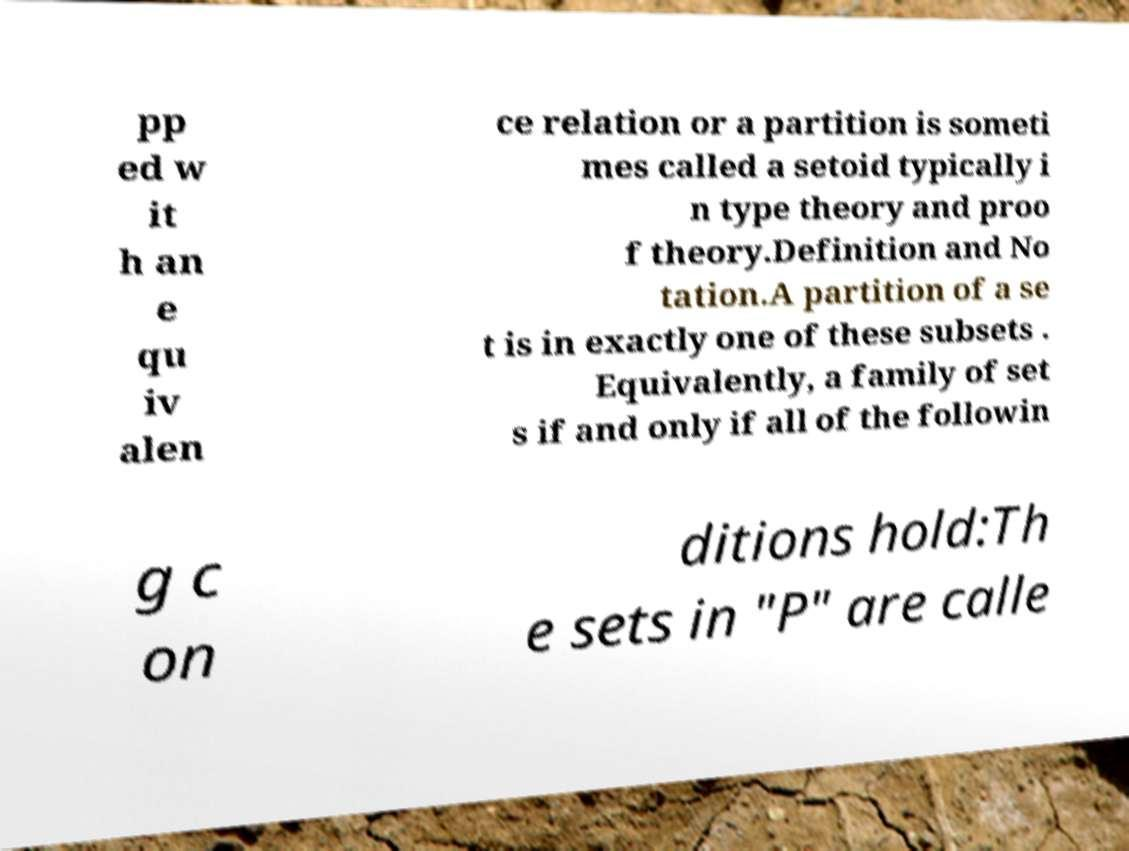There's text embedded in this image that I need extracted. Can you transcribe it verbatim? pp ed w it h an e qu iv alen ce relation or a partition is someti mes called a setoid typically i n type theory and proo f theory.Definition and No tation.A partition of a se t is in exactly one of these subsets . Equivalently, a family of set s if and only if all of the followin g c on ditions hold:Th e sets in "P" are calle 